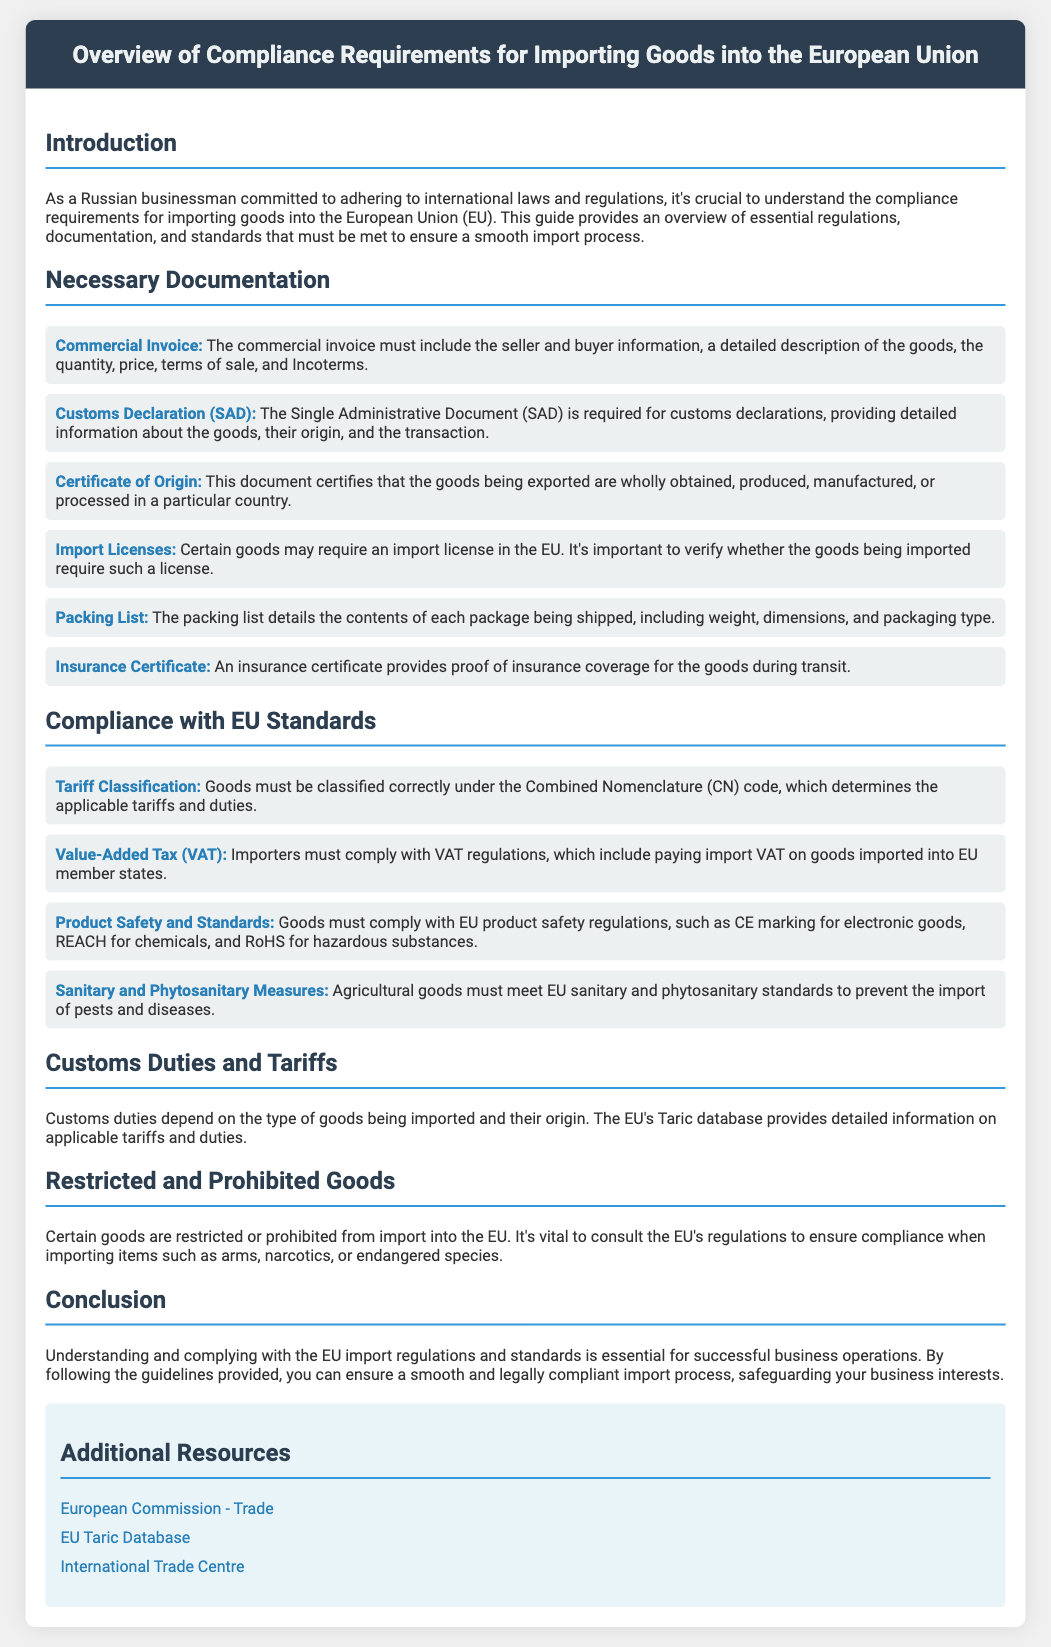What is the first necessary document for importing goods? The first necessary document listed for importing goods is the Commercial Invoice.
Answer: Commercial Invoice What does the Customs Declaration document provide? The Customs Declaration (SAD) provides detailed information about the goods, their origin, and the transaction.
Answer: Detailed information What is the purpose of the Certificate of Origin? The Certificate of Origin certifies that the goods are wholly obtained, produced, manufactured, or processed in a particular country.
Answer: Certifies origin Which code determines the applicable tariffs and duties? The Combined Nomenclature (CN) code determines the applicable tariffs and duties.
Answer: Combined Nomenclature What tax must importers comply with when importing into EU member states? Importers must comply with Value-Added Tax (VAT) regulations.
Answer: Value-Added Tax (VAT) What does the EU Taric database provide information about? The EU Taric database provides detailed information on applicable tariffs and duties.
Answer: Tariffs and duties Name a type of good that is prohibited from import into the EU. Arms are an example of a type of good that is prohibited from import.
Answer: Arms What must certain agricultural goods meet to prevent pests and diseases? Certain agricultural goods must meet EU sanitary and phytosanitary standards.
Answer: Sanitary and phytosanitary standards Which organization's website is listed as a resource for trade? The European Commission's website is listed as a resource for trade.
Answer: European Commission 